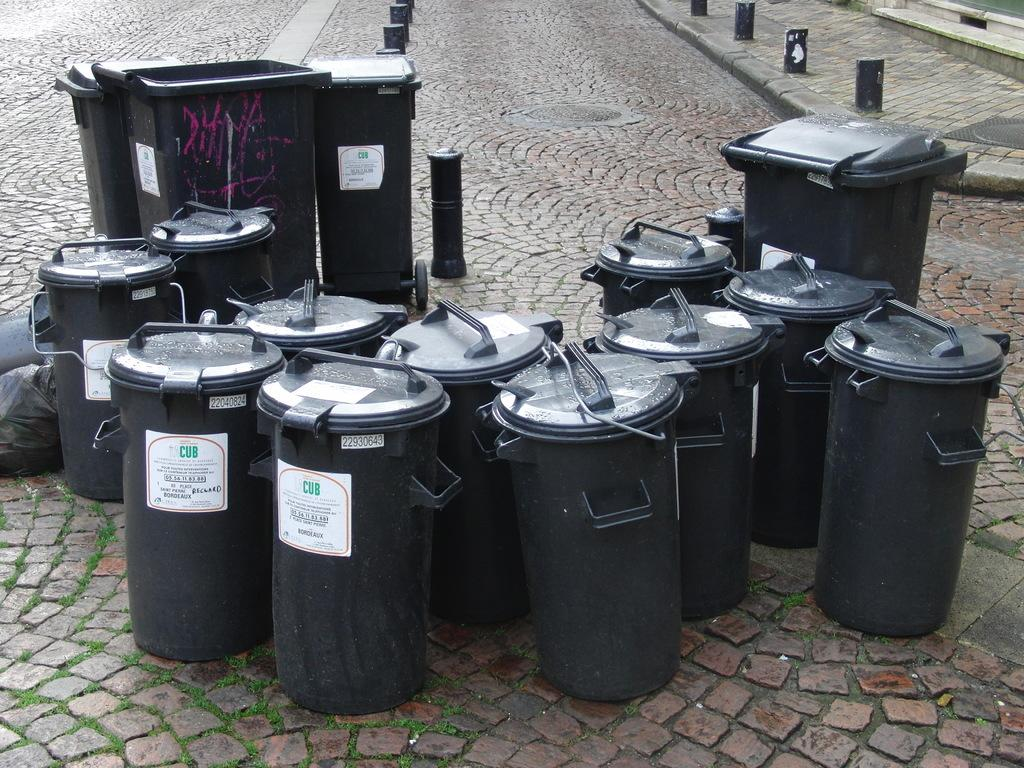<image>
Render a clear and concise summary of the photo. Some black bins display white labels and green letters that spell out CUB sit outside. 